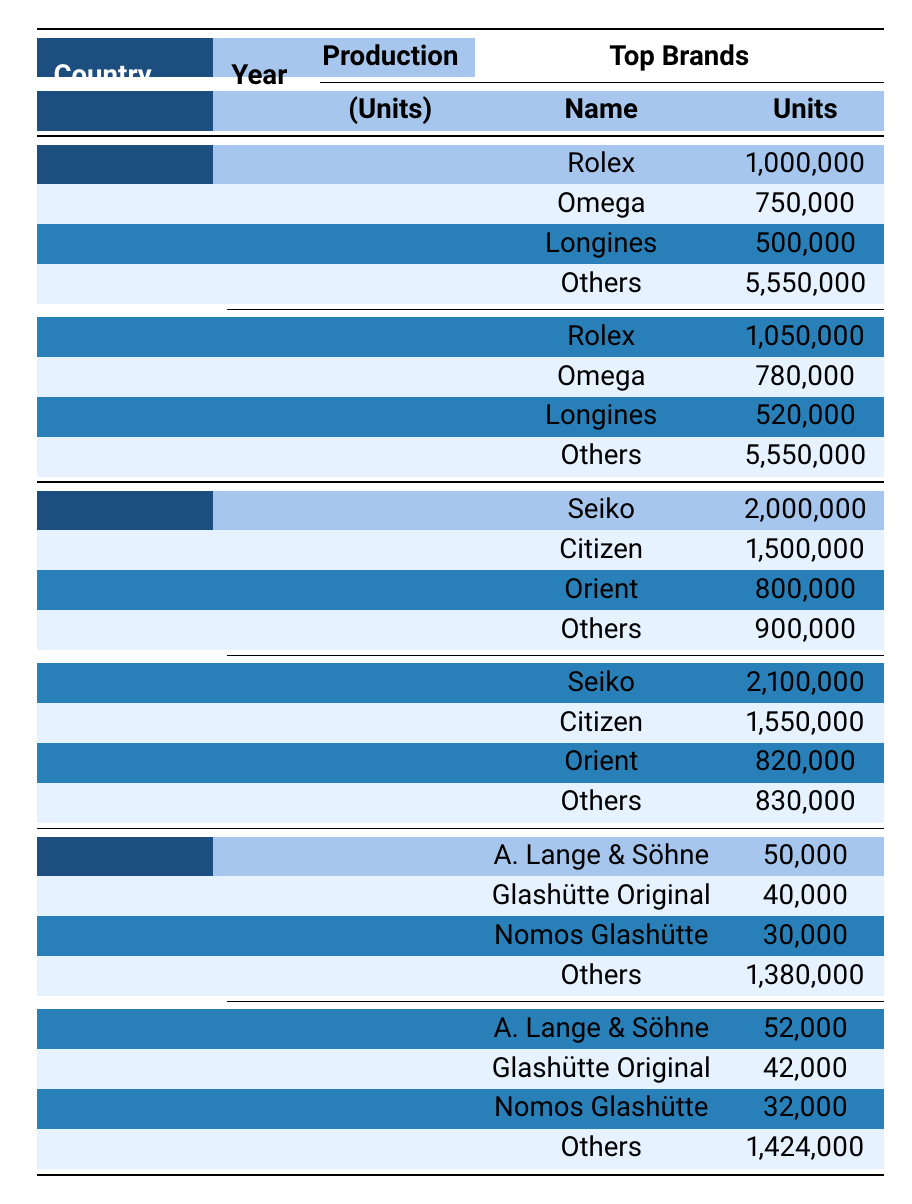What was the total production of mechanical wristwatches in Switzerland in 2019? In 2019, the total production of mechanical wristwatches in Switzerland was listed as 7,900,000 units in the table.
Answer: 7,900,000 Which country produced more wristwatches in 2018, Japan or Germany? The table shows that Japan produced 5,200,000 units, while Germany produced 1,500,000 units in 2018. Since 5,200,000 is greater than 1,500,000, Japan produced more wristwatches.
Answer: Japan What percentage of Switzerland's total production in 2019 was accounted for by Rolex? Rolex produced 1,050,000 units out of 7,900,000 total units in 2019. To find the percentage, divide 1,050,000 by 7,900,000, which equals approximately 0.1339 or 13.39%.
Answer: 13.39% How many more wristwatches did Japan produce in 2019 compared to 2018? In 2019, Japan produced 5,300,000 units, and in 2018, they produced 5,200,000 units. The difference is 5,300,000 - 5,200,000 = 100,000 units.
Answer: 100,000 What was the total production of all countries combined in 2018? In 2018, Switzerland produced 7,800,000, Japan produced 5,200,000, and Germany produced 1,500,000. Adding these gives 7,800,000 + 5,200,000 + 1,500,000 = 14,500,000 units in total.
Answer: 14,500,000 Did A. Lange & Söhne produce more wristwatches in 2019 than in 2018? In 2018, A. Lange & Söhne produced 50,000 units, and in 2019, they produced 52,000 units. Since 52,000 is greater than 50,000, they produced more wristwatches in 2019.
Answer: Yes What country had the highest wristwatch production in 2018? The highest production in 2018 was from Switzerland, with a total of 7,800,000 units produced, which is more than Japan's 5,200,000 and Germany's 1,500,000.
Answer: Switzerland Calculate the average production of mechanical wristwatches per year for Germany from 2018 to 2019. Germany's production was 1,500,000 in 2018 and 1,550,000 in 2019. Adding these gives 1,500,000 + 1,550,000 = 3,050,000. The average for two years is 3,050,000 / 2 = 1,525,000.
Answer: 1,525,000 Which brand accounted for less than 100,000 units in Germany in both years? In 2018, Nomos Glashütte produced 30,000 units, and in 2019, they produced 32,000. Both are less than 100,000 units.
Answer: Nomos Glashütte What can be inferred about the production trend of Seiko from 2018 to 2019? Seiko's production increased from 2,000,000 units in 2018 to 2,100,000 units in 2019, indicating an upward trend.
Answer: Increasing Which country had a consistent "Others" category production, and what was that value? Switzerland had a consistent "Others" category production of 5,550,000 in both 2018 and 2019.
Answer: 5,550,000 